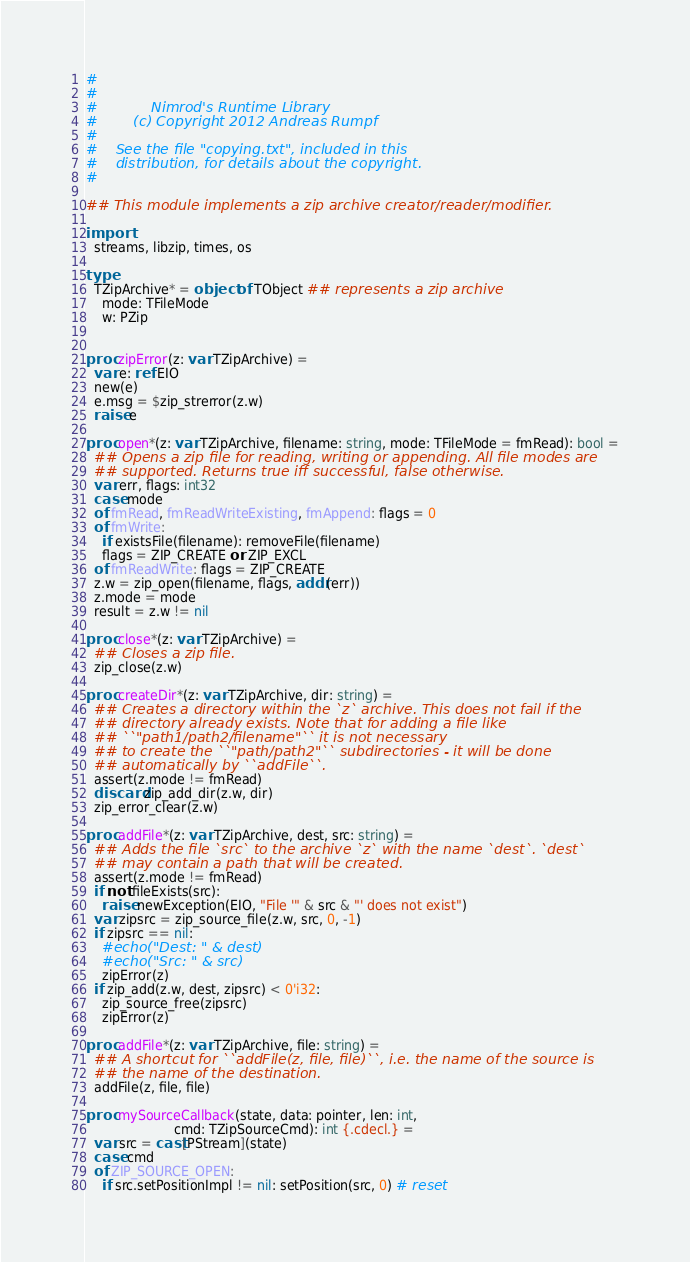<code> <loc_0><loc_0><loc_500><loc_500><_Nim_>#
#
#            Nimrod's Runtime Library
#        (c) Copyright 2012 Andreas Rumpf
#
#    See the file "copying.txt", included in this
#    distribution, for details about the copyright.
#

## This module implements a zip archive creator/reader/modifier.

import 
  streams, libzip, times, os

type
  TZipArchive* = object of TObject ## represents a zip archive
    mode: TFileMode
    w: PZip


proc zipError(z: var TZipArchive) = 
  var e: ref EIO
  new(e)
  e.msg = $zip_strerror(z.w)
  raise e
  
proc open*(z: var TZipArchive, filename: string, mode: TFileMode = fmRead): bool =
  ## Opens a zip file for reading, writing or appending. All file modes are 
  ## supported. Returns true iff successful, false otherwise.
  var err, flags: int32
  case mode
  of fmRead, fmReadWriteExisting, fmAppend: flags = 0
  of fmWrite:
    if existsFile(filename): removeFile(filename)
    flags = ZIP_CREATE or ZIP_EXCL
  of fmReadWrite: flags = ZIP_CREATE
  z.w = zip_open(filename, flags, addr(err))
  z.mode = mode
  result = z.w != nil

proc close*(z: var TZipArchive) =
  ## Closes a zip file.
  zip_close(z.w)
 
proc createDir*(z: var TZipArchive, dir: string) = 
  ## Creates a directory within the `z` archive. This does not fail if the
  ## directory already exists. Note that for adding a file like 
  ## ``"path1/path2/filename"`` it is not necessary
  ## to create the ``"path/path2"`` subdirectories - it will be done 
  ## automatically by ``addFile``. 
  assert(z.mode != fmRead) 
  discard zip_add_dir(z.w, dir)
  zip_error_clear(z.w)

proc addFile*(z: var TZipArchive, dest, src: string) = 
  ## Adds the file `src` to the archive `z` with the name `dest`. `dest`
  ## may contain a path that will be created. 
  assert(z.mode != fmRead) 
  if not fileExists(src):
    raise newException(EIO, "File '" & src & "' does not exist")
  var zipsrc = zip_source_file(z.w, src, 0, -1)
  if zipsrc == nil:
    #echo("Dest: " & dest)
    #echo("Src: " & src)
    zipError(z)
  if zip_add(z.w, dest, zipsrc) < 0'i32:
    zip_source_free(zipsrc)
    zipError(z)

proc addFile*(z: var TZipArchive, file: string) = 
  ## A shortcut for ``addFile(z, file, file)``, i.e. the name of the source is
  ## the name of the destination.
  addFile(z, file, file)
  
proc mySourceCallback(state, data: pointer, len: int, 
                      cmd: TZipSourceCmd): int {.cdecl.} = 
  var src = cast[PStream](state)
  case cmd
  of ZIP_SOURCE_OPEN: 
    if src.setPositionImpl != nil: setPosition(src, 0) # reset</code> 